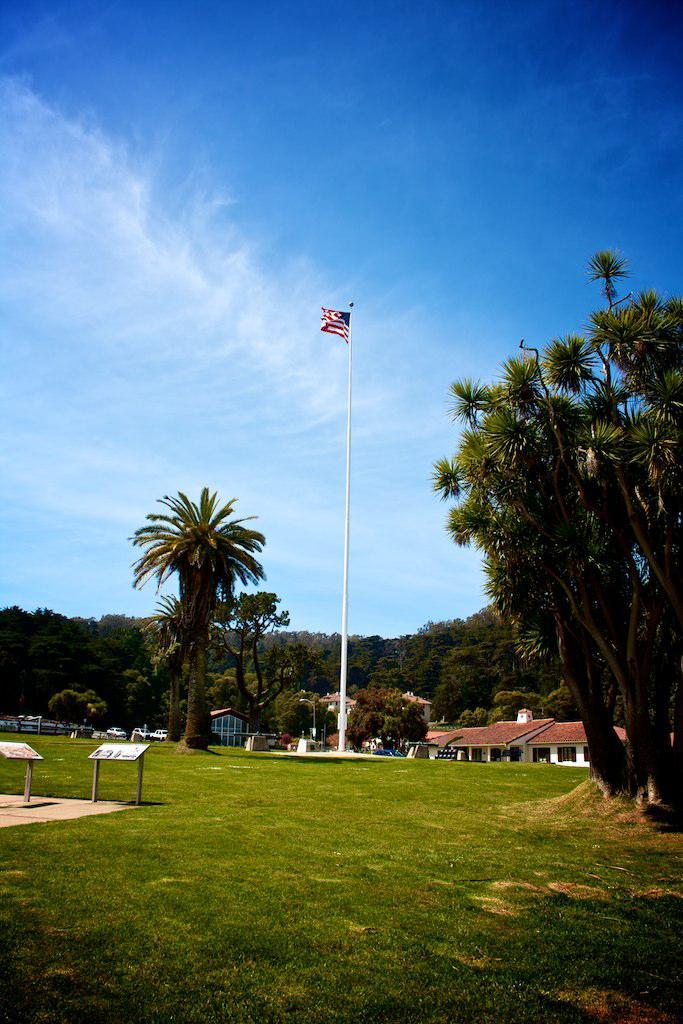What is the color of the sky in the image? The sky is clear and blue at the top of the image. What can be seen in the background of the image? There are trees and houses in the background of the image. What object is present in the image that represents a country or organization? There is a flag in the image. What type of vegetation is visible in the image? There is grass visible in the image. Can you describe the tree on the right side of the image? Yes, there is a tree on the right side of the image. What type of drum can be heard playing in the background of the image? There is no drum or sound present in the image; it is a still image with no audio component. 